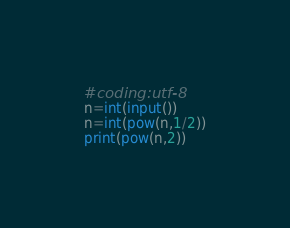Convert code to text. <code><loc_0><loc_0><loc_500><loc_500><_Python_>#coding:utf-8
n=int(input())
n=int(pow(n,1/2))
print(pow(n,2))</code> 